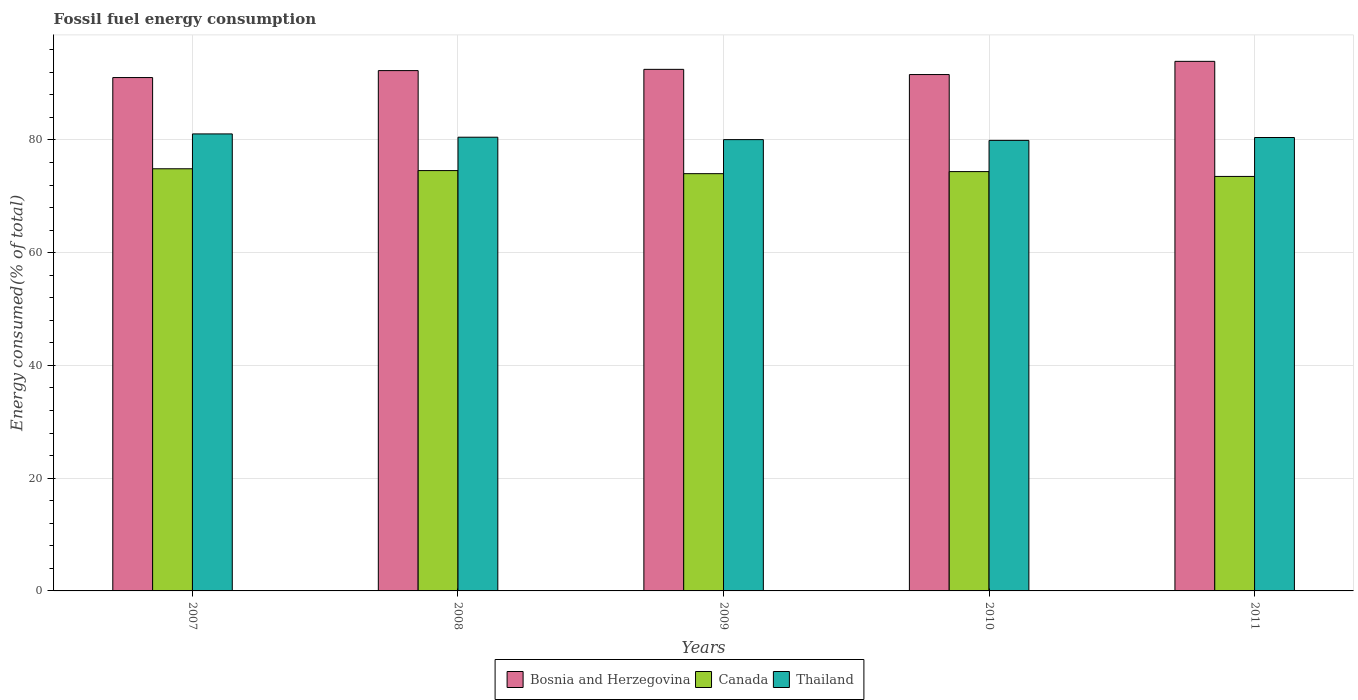How many different coloured bars are there?
Offer a very short reply. 3. How many groups of bars are there?
Offer a terse response. 5. Are the number of bars per tick equal to the number of legend labels?
Your answer should be very brief. Yes. Are the number of bars on each tick of the X-axis equal?
Keep it short and to the point. Yes. How many bars are there on the 3rd tick from the left?
Provide a short and direct response. 3. What is the label of the 1st group of bars from the left?
Offer a very short reply. 2007. What is the percentage of energy consumed in Canada in 2009?
Your answer should be compact. 74.02. Across all years, what is the maximum percentage of energy consumed in Canada?
Make the answer very short. 74.89. Across all years, what is the minimum percentage of energy consumed in Bosnia and Herzegovina?
Your answer should be very brief. 91.07. What is the total percentage of energy consumed in Bosnia and Herzegovina in the graph?
Provide a short and direct response. 461.45. What is the difference between the percentage of energy consumed in Canada in 2008 and that in 2011?
Provide a succinct answer. 1.04. What is the difference between the percentage of energy consumed in Bosnia and Herzegovina in 2007 and the percentage of energy consumed in Canada in 2009?
Your answer should be compact. 17.05. What is the average percentage of energy consumed in Thailand per year?
Keep it short and to the point. 80.4. In the year 2009, what is the difference between the percentage of energy consumed in Thailand and percentage of energy consumed in Canada?
Provide a short and direct response. 6.04. What is the ratio of the percentage of energy consumed in Canada in 2008 to that in 2010?
Your answer should be compact. 1. Is the percentage of energy consumed in Bosnia and Herzegovina in 2007 less than that in 2010?
Your answer should be very brief. Yes. Is the difference between the percentage of energy consumed in Thailand in 2007 and 2009 greater than the difference between the percentage of energy consumed in Canada in 2007 and 2009?
Make the answer very short. Yes. What is the difference between the highest and the second highest percentage of energy consumed in Thailand?
Keep it short and to the point. 0.58. What is the difference between the highest and the lowest percentage of energy consumed in Bosnia and Herzegovina?
Your response must be concise. 2.87. In how many years, is the percentage of energy consumed in Thailand greater than the average percentage of energy consumed in Thailand taken over all years?
Provide a succinct answer. 3. What does the 1st bar from the left in 2007 represents?
Provide a succinct answer. Bosnia and Herzegovina. What does the 2nd bar from the right in 2008 represents?
Keep it short and to the point. Canada. Are all the bars in the graph horizontal?
Keep it short and to the point. No. Are the values on the major ticks of Y-axis written in scientific E-notation?
Provide a succinct answer. No. Does the graph contain any zero values?
Your response must be concise. No. Does the graph contain grids?
Your response must be concise. Yes. Where does the legend appear in the graph?
Offer a terse response. Bottom center. What is the title of the graph?
Offer a terse response. Fossil fuel energy consumption. What is the label or title of the Y-axis?
Offer a very short reply. Energy consumed(% of total). What is the Energy consumed(% of total) of Bosnia and Herzegovina in 2007?
Make the answer very short. 91.07. What is the Energy consumed(% of total) in Canada in 2007?
Your answer should be very brief. 74.89. What is the Energy consumed(% of total) in Thailand in 2007?
Provide a succinct answer. 81.07. What is the Energy consumed(% of total) in Bosnia and Herzegovina in 2008?
Offer a very short reply. 92.3. What is the Energy consumed(% of total) in Canada in 2008?
Keep it short and to the point. 74.57. What is the Energy consumed(% of total) of Thailand in 2008?
Give a very brief answer. 80.49. What is the Energy consumed(% of total) in Bosnia and Herzegovina in 2009?
Provide a short and direct response. 92.53. What is the Energy consumed(% of total) of Canada in 2009?
Provide a succinct answer. 74.02. What is the Energy consumed(% of total) in Thailand in 2009?
Your answer should be very brief. 80.06. What is the Energy consumed(% of total) in Bosnia and Herzegovina in 2010?
Offer a very short reply. 91.6. What is the Energy consumed(% of total) of Canada in 2010?
Offer a terse response. 74.39. What is the Energy consumed(% of total) of Thailand in 2010?
Your response must be concise. 79.93. What is the Energy consumed(% of total) in Bosnia and Herzegovina in 2011?
Keep it short and to the point. 93.95. What is the Energy consumed(% of total) of Canada in 2011?
Your answer should be compact. 73.53. What is the Energy consumed(% of total) of Thailand in 2011?
Ensure brevity in your answer.  80.44. Across all years, what is the maximum Energy consumed(% of total) of Bosnia and Herzegovina?
Make the answer very short. 93.95. Across all years, what is the maximum Energy consumed(% of total) in Canada?
Your answer should be compact. 74.89. Across all years, what is the maximum Energy consumed(% of total) in Thailand?
Your response must be concise. 81.07. Across all years, what is the minimum Energy consumed(% of total) in Bosnia and Herzegovina?
Make the answer very short. 91.07. Across all years, what is the minimum Energy consumed(% of total) in Canada?
Your response must be concise. 73.53. Across all years, what is the minimum Energy consumed(% of total) of Thailand?
Your answer should be compact. 79.93. What is the total Energy consumed(% of total) in Bosnia and Herzegovina in the graph?
Provide a short and direct response. 461.45. What is the total Energy consumed(% of total) in Canada in the graph?
Offer a very short reply. 371.4. What is the total Energy consumed(% of total) of Thailand in the graph?
Keep it short and to the point. 401.99. What is the difference between the Energy consumed(% of total) of Bosnia and Herzegovina in 2007 and that in 2008?
Your response must be concise. -1.23. What is the difference between the Energy consumed(% of total) of Canada in 2007 and that in 2008?
Make the answer very short. 0.32. What is the difference between the Energy consumed(% of total) in Thailand in 2007 and that in 2008?
Keep it short and to the point. 0.58. What is the difference between the Energy consumed(% of total) of Bosnia and Herzegovina in 2007 and that in 2009?
Provide a succinct answer. -1.45. What is the difference between the Energy consumed(% of total) in Canada in 2007 and that in 2009?
Provide a short and direct response. 0.87. What is the difference between the Energy consumed(% of total) of Thailand in 2007 and that in 2009?
Offer a terse response. 1.01. What is the difference between the Energy consumed(% of total) in Bosnia and Herzegovina in 2007 and that in 2010?
Ensure brevity in your answer.  -0.53. What is the difference between the Energy consumed(% of total) of Canada in 2007 and that in 2010?
Your response must be concise. 0.5. What is the difference between the Energy consumed(% of total) of Thailand in 2007 and that in 2010?
Ensure brevity in your answer.  1.15. What is the difference between the Energy consumed(% of total) of Bosnia and Herzegovina in 2007 and that in 2011?
Your answer should be compact. -2.87. What is the difference between the Energy consumed(% of total) of Canada in 2007 and that in 2011?
Ensure brevity in your answer.  1.36. What is the difference between the Energy consumed(% of total) of Thailand in 2007 and that in 2011?
Your answer should be compact. 0.64. What is the difference between the Energy consumed(% of total) of Bosnia and Herzegovina in 2008 and that in 2009?
Give a very brief answer. -0.22. What is the difference between the Energy consumed(% of total) of Canada in 2008 and that in 2009?
Keep it short and to the point. 0.55. What is the difference between the Energy consumed(% of total) of Thailand in 2008 and that in 2009?
Ensure brevity in your answer.  0.43. What is the difference between the Energy consumed(% of total) of Bosnia and Herzegovina in 2008 and that in 2010?
Provide a short and direct response. 0.7. What is the difference between the Energy consumed(% of total) of Canada in 2008 and that in 2010?
Your response must be concise. 0.18. What is the difference between the Energy consumed(% of total) in Thailand in 2008 and that in 2010?
Offer a very short reply. 0.56. What is the difference between the Energy consumed(% of total) of Bosnia and Herzegovina in 2008 and that in 2011?
Your answer should be very brief. -1.64. What is the difference between the Energy consumed(% of total) in Canada in 2008 and that in 2011?
Provide a short and direct response. 1.04. What is the difference between the Energy consumed(% of total) of Thailand in 2008 and that in 2011?
Make the answer very short. 0.05. What is the difference between the Energy consumed(% of total) in Bosnia and Herzegovina in 2009 and that in 2010?
Provide a succinct answer. 0.92. What is the difference between the Energy consumed(% of total) in Canada in 2009 and that in 2010?
Provide a succinct answer. -0.37. What is the difference between the Energy consumed(% of total) of Thailand in 2009 and that in 2010?
Your response must be concise. 0.14. What is the difference between the Energy consumed(% of total) of Bosnia and Herzegovina in 2009 and that in 2011?
Offer a very short reply. -1.42. What is the difference between the Energy consumed(% of total) of Canada in 2009 and that in 2011?
Your answer should be compact. 0.49. What is the difference between the Energy consumed(% of total) in Thailand in 2009 and that in 2011?
Provide a short and direct response. -0.37. What is the difference between the Energy consumed(% of total) in Bosnia and Herzegovina in 2010 and that in 2011?
Keep it short and to the point. -2.34. What is the difference between the Energy consumed(% of total) of Canada in 2010 and that in 2011?
Give a very brief answer. 0.86. What is the difference between the Energy consumed(% of total) in Thailand in 2010 and that in 2011?
Keep it short and to the point. -0.51. What is the difference between the Energy consumed(% of total) in Bosnia and Herzegovina in 2007 and the Energy consumed(% of total) in Canada in 2008?
Provide a succinct answer. 16.5. What is the difference between the Energy consumed(% of total) of Bosnia and Herzegovina in 2007 and the Energy consumed(% of total) of Thailand in 2008?
Keep it short and to the point. 10.58. What is the difference between the Energy consumed(% of total) of Canada in 2007 and the Energy consumed(% of total) of Thailand in 2008?
Offer a very short reply. -5.6. What is the difference between the Energy consumed(% of total) of Bosnia and Herzegovina in 2007 and the Energy consumed(% of total) of Canada in 2009?
Make the answer very short. 17.05. What is the difference between the Energy consumed(% of total) of Bosnia and Herzegovina in 2007 and the Energy consumed(% of total) of Thailand in 2009?
Offer a very short reply. 11.01. What is the difference between the Energy consumed(% of total) in Canada in 2007 and the Energy consumed(% of total) in Thailand in 2009?
Your answer should be very brief. -5.17. What is the difference between the Energy consumed(% of total) of Bosnia and Herzegovina in 2007 and the Energy consumed(% of total) of Canada in 2010?
Keep it short and to the point. 16.68. What is the difference between the Energy consumed(% of total) of Bosnia and Herzegovina in 2007 and the Energy consumed(% of total) of Thailand in 2010?
Keep it short and to the point. 11.15. What is the difference between the Energy consumed(% of total) in Canada in 2007 and the Energy consumed(% of total) in Thailand in 2010?
Your response must be concise. -5.04. What is the difference between the Energy consumed(% of total) of Bosnia and Herzegovina in 2007 and the Energy consumed(% of total) of Canada in 2011?
Offer a terse response. 17.54. What is the difference between the Energy consumed(% of total) of Bosnia and Herzegovina in 2007 and the Energy consumed(% of total) of Thailand in 2011?
Keep it short and to the point. 10.64. What is the difference between the Energy consumed(% of total) of Canada in 2007 and the Energy consumed(% of total) of Thailand in 2011?
Offer a very short reply. -5.55. What is the difference between the Energy consumed(% of total) in Bosnia and Herzegovina in 2008 and the Energy consumed(% of total) in Canada in 2009?
Offer a terse response. 18.28. What is the difference between the Energy consumed(% of total) of Bosnia and Herzegovina in 2008 and the Energy consumed(% of total) of Thailand in 2009?
Make the answer very short. 12.24. What is the difference between the Energy consumed(% of total) of Canada in 2008 and the Energy consumed(% of total) of Thailand in 2009?
Your answer should be very brief. -5.5. What is the difference between the Energy consumed(% of total) in Bosnia and Herzegovina in 2008 and the Energy consumed(% of total) in Canada in 2010?
Provide a short and direct response. 17.92. What is the difference between the Energy consumed(% of total) in Bosnia and Herzegovina in 2008 and the Energy consumed(% of total) in Thailand in 2010?
Offer a terse response. 12.38. What is the difference between the Energy consumed(% of total) of Canada in 2008 and the Energy consumed(% of total) of Thailand in 2010?
Offer a terse response. -5.36. What is the difference between the Energy consumed(% of total) of Bosnia and Herzegovina in 2008 and the Energy consumed(% of total) of Canada in 2011?
Make the answer very short. 18.77. What is the difference between the Energy consumed(% of total) of Bosnia and Herzegovina in 2008 and the Energy consumed(% of total) of Thailand in 2011?
Provide a short and direct response. 11.87. What is the difference between the Energy consumed(% of total) of Canada in 2008 and the Energy consumed(% of total) of Thailand in 2011?
Make the answer very short. -5.87. What is the difference between the Energy consumed(% of total) of Bosnia and Herzegovina in 2009 and the Energy consumed(% of total) of Canada in 2010?
Offer a very short reply. 18.14. What is the difference between the Energy consumed(% of total) of Bosnia and Herzegovina in 2009 and the Energy consumed(% of total) of Thailand in 2010?
Make the answer very short. 12.6. What is the difference between the Energy consumed(% of total) of Canada in 2009 and the Energy consumed(% of total) of Thailand in 2010?
Offer a very short reply. -5.9. What is the difference between the Energy consumed(% of total) of Bosnia and Herzegovina in 2009 and the Energy consumed(% of total) of Canada in 2011?
Make the answer very short. 18.99. What is the difference between the Energy consumed(% of total) of Bosnia and Herzegovina in 2009 and the Energy consumed(% of total) of Thailand in 2011?
Keep it short and to the point. 12.09. What is the difference between the Energy consumed(% of total) of Canada in 2009 and the Energy consumed(% of total) of Thailand in 2011?
Provide a short and direct response. -6.41. What is the difference between the Energy consumed(% of total) in Bosnia and Herzegovina in 2010 and the Energy consumed(% of total) in Canada in 2011?
Your response must be concise. 18.07. What is the difference between the Energy consumed(% of total) in Bosnia and Herzegovina in 2010 and the Energy consumed(% of total) in Thailand in 2011?
Your answer should be very brief. 11.17. What is the difference between the Energy consumed(% of total) of Canada in 2010 and the Energy consumed(% of total) of Thailand in 2011?
Provide a succinct answer. -6.05. What is the average Energy consumed(% of total) in Bosnia and Herzegovina per year?
Offer a very short reply. 92.29. What is the average Energy consumed(% of total) of Canada per year?
Your answer should be compact. 74.28. What is the average Energy consumed(% of total) of Thailand per year?
Your response must be concise. 80.4. In the year 2007, what is the difference between the Energy consumed(% of total) in Bosnia and Herzegovina and Energy consumed(% of total) in Canada?
Provide a short and direct response. 16.18. In the year 2007, what is the difference between the Energy consumed(% of total) in Bosnia and Herzegovina and Energy consumed(% of total) in Thailand?
Keep it short and to the point. 10. In the year 2007, what is the difference between the Energy consumed(% of total) of Canada and Energy consumed(% of total) of Thailand?
Give a very brief answer. -6.18. In the year 2008, what is the difference between the Energy consumed(% of total) of Bosnia and Herzegovina and Energy consumed(% of total) of Canada?
Provide a succinct answer. 17.74. In the year 2008, what is the difference between the Energy consumed(% of total) of Bosnia and Herzegovina and Energy consumed(% of total) of Thailand?
Offer a terse response. 11.82. In the year 2008, what is the difference between the Energy consumed(% of total) of Canada and Energy consumed(% of total) of Thailand?
Ensure brevity in your answer.  -5.92. In the year 2009, what is the difference between the Energy consumed(% of total) of Bosnia and Herzegovina and Energy consumed(% of total) of Canada?
Your answer should be compact. 18.5. In the year 2009, what is the difference between the Energy consumed(% of total) in Bosnia and Herzegovina and Energy consumed(% of total) in Thailand?
Offer a terse response. 12.46. In the year 2009, what is the difference between the Energy consumed(% of total) in Canada and Energy consumed(% of total) in Thailand?
Give a very brief answer. -6.04. In the year 2010, what is the difference between the Energy consumed(% of total) of Bosnia and Herzegovina and Energy consumed(% of total) of Canada?
Your response must be concise. 17.22. In the year 2010, what is the difference between the Energy consumed(% of total) of Bosnia and Herzegovina and Energy consumed(% of total) of Thailand?
Provide a short and direct response. 11.68. In the year 2010, what is the difference between the Energy consumed(% of total) in Canada and Energy consumed(% of total) in Thailand?
Offer a terse response. -5.54. In the year 2011, what is the difference between the Energy consumed(% of total) of Bosnia and Herzegovina and Energy consumed(% of total) of Canada?
Offer a terse response. 20.41. In the year 2011, what is the difference between the Energy consumed(% of total) in Bosnia and Herzegovina and Energy consumed(% of total) in Thailand?
Keep it short and to the point. 13.51. In the year 2011, what is the difference between the Energy consumed(% of total) in Canada and Energy consumed(% of total) in Thailand?
Ensure brevity in your answer.  -6.9. What is the ratio of the Energy consumed(% of total) of Bosnia and Herzegovina in 2007 to that in 2008?
Your response must be concise. 0.99. What is the ratio of the Energy consumed(% of total) of Thailand in 2007 to that in 2008?
Your answer should be very brief. 1.01. What is the ratio of the Energy consumed(% of total) of Bosnia and Herzegovina in 2007 to that in 2009?
Your response must be concise. 0.98. What is the ratio of the Energy consumed(% of total) of Canada in 2007 to that in 2009?
Give a very brief answer. 1.01. What is the ratio of the Energy consumed(% of total) in Thailand in 2007 to that in 2009?
Provide a short and direct response. 1.01. What is the ratio of the Energy consumed(% of total) of Bosnia and Herzegovina in 2007 to that in 2010?
Your answer should be very brief. 0.99. What is the ratio of the Energy consumed(% of total) in Thailand in 2007 to that in 2010?
Give a very brief answer. 1.01. What is the ratio of the Energy consumed(% of total) in Bosnia and Herzegovina in 2007 to that in 2011?
Offer a terse response. 0.97. What is the ratio of the Energy consumed(% of total) in Canada in 2007 to that in 2011?
Make the answer very short. 1.02. What is the ratio of the Energy consumed(% of total) of Thailand in 2007 to that in 2011?
Provide a short and direct response. 1.01. What is the ratio of the Energy consumed(% of total) of Canada in 2008 to that in 2009?
Your answer should be compact. 1.01. What is the ratio of the Energy consumed(% of total) in Bosnia and Herzegovina in 2008 to that in 2010?
Your answer should be compact. 1.01. What is the ratio of the Energy consumed(% of total) in Bosnia and Herzegovina in 2008 to that in 2011?
Offer a very short reply. 0.98. What is the ratio of the Energy consumed(% of total) of Canada in 2008 to that in 2011?
Ensure brevity in your answer.  1.01. What is the ratio of the Energy consumed(% of total) of Thailand in 2008 to that in 2011?
Your answer should be very brief. 1. What is the ratio of the Energy consumed(% of total) in Bosnia and Herzegovina in 2009 to that in 2010?
Ensure brevity in your answer.  1.01. What is the ratio of the Energy consumed(% of total) of Bosnia and Herzegovina in 2009 to that in 2011?
Keep it short and to the point. 0.98. What is the ratio of the Energy consumed(% of total) of Canada in 2009 to that in 2011?
Offer a terse response. 1.01. What is the ratio of the Energy consumed(% of total) of Thailand in 2009 to that in 2011?
Offer a very short reply. 1. What is the ratio of the Energy consumed(% of total) of Bosnia and Herzegovina in 2010 to that in 2011?
Keep it short and to the point. 0.98. What is the ratio of the Energy consumed(% of total) in Canada in 2010 to that in 2011?
Your answer should be compact. 1.01. What is the ratio of the Energy consumed(% of total) of Thailand in 2010 to that in 2011?
Your answer should be compact. 0.99. What is the difference between the highest and the second highest Energy consumed(% of total) in Bosnia and Herzegovina?
Offer a terse response. 1.42. What is the difference between the highest and the second highest Energy consumed(% of total) in Canada?
Your response must be concise. 0.32. What is the difference between the highest and the second highest Energy consumed(% of total) in Thailand?
Your answer should be very brief. 0.58. What is the difference between the highest and the lowest Energy consumed(% of total) of Bosnia and Herzegovina?
Provide a short and direct response. 2.87. What is the difference between the highest and the lowest Energy consumed(% of total) of Canada?
Provide a succinct answer. 1.36. What is the difference between the highest and the lowest Energy consumed(% of total) in Thailand?
Provide a short and direct response. 1.15. 